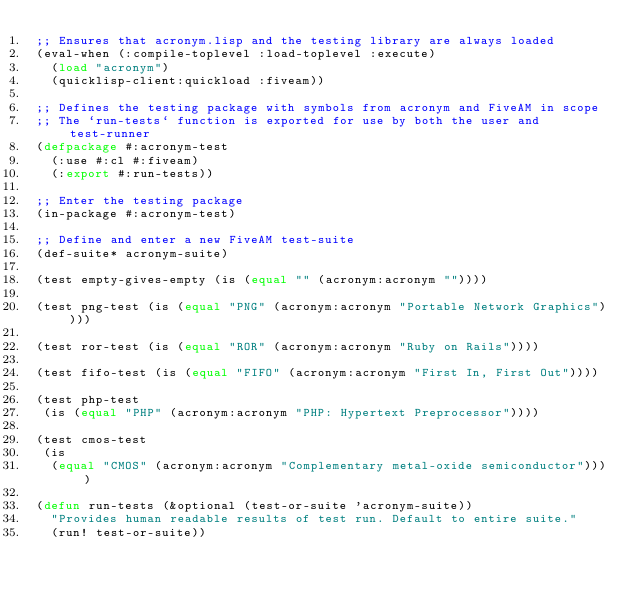<code> <loc_0><loc_0><loc_500><loc_500><_Lisp_>;; Ensures that acronym.lisp and the testing library are always loaded
(eval-when (:compile-toplevel :load-toplevel :execute)
  (load "acronym")
  (quicklisp-client:quickload :fiveam))

;; Defines the testing package with symbols from acronym and FiveAM in scope
;; The `run-tests` function is exported for use by both the user and test-runner
(defpackage #:acronym-test
  (:use #:cl #:fiveam)
  (:export #:run-tests))

;; Enter the testing package
(in-package #:acronym-test)

;; Define and enter a new FiveAM test-suite
(def-suite* acronym-suite)

(test empty-gives-empty (is (equal "" (acronym:acronym ""))))

(test png-test (is (equal "PNG" (acronym:acronym "Portable Network Graphics"))))

(test ror-test (is (equal "ROR" (acronym:acronym "Ruby on Rails"))))

(test fifo-test (is (equal "FIFO" (acronym:acronym "First In, First Out"))))

(test php-test
 (is (equal "PHP" (acronym:acronym "PHP: Hypertext Preprocessor"))))

(test cmos-test
 (is
  (equal "CMOS" (acronym:acronym "Complementary metal-oxide semiconductor"))))

(defun run-tests (&optional (test-or-suite 'acronym-suite))
  "Provides human readable results of test run. Default to entire suite."
  (run! test-or-suite))
</code> 